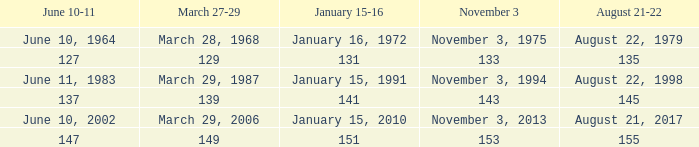What is the number for march 27-29 whern november 3 is 153? 149.0. 